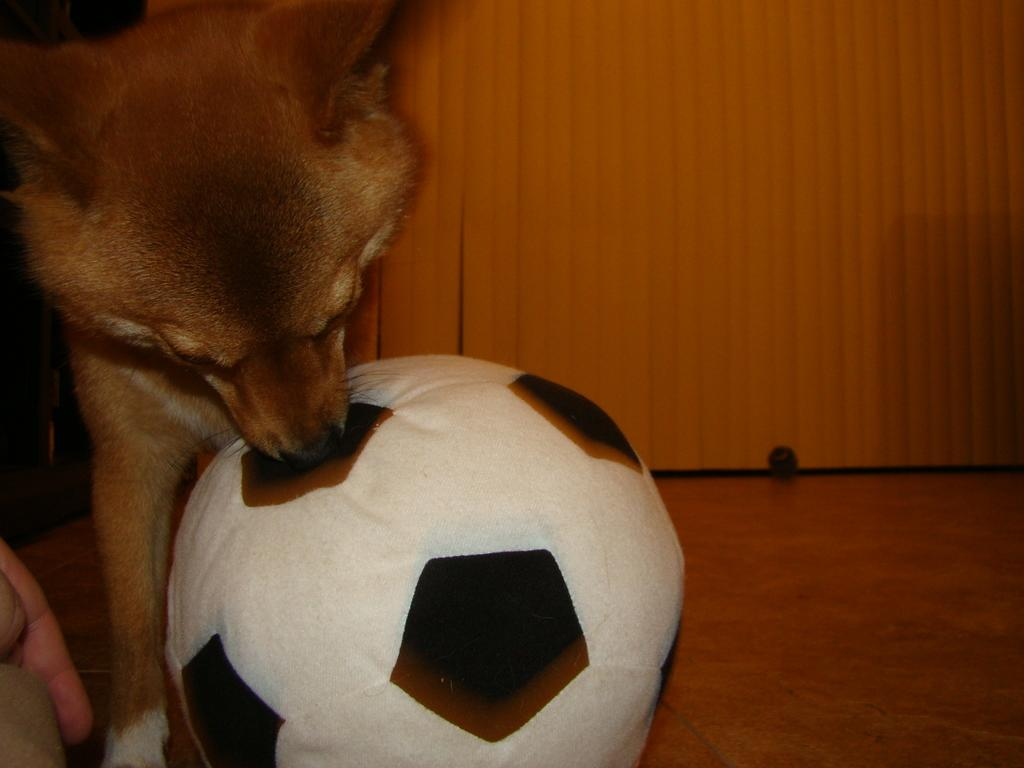What animal is on the floor in the image? There is a dog on the floor in the image. What object can be seen in the image besides the dog? There is a ball in the image. What color is the background of the image? The background color is orange. What type of pan is being used to cook the cream in the image? There is no pan or cream present in the image; it features a dog and a ball on an orange background. 